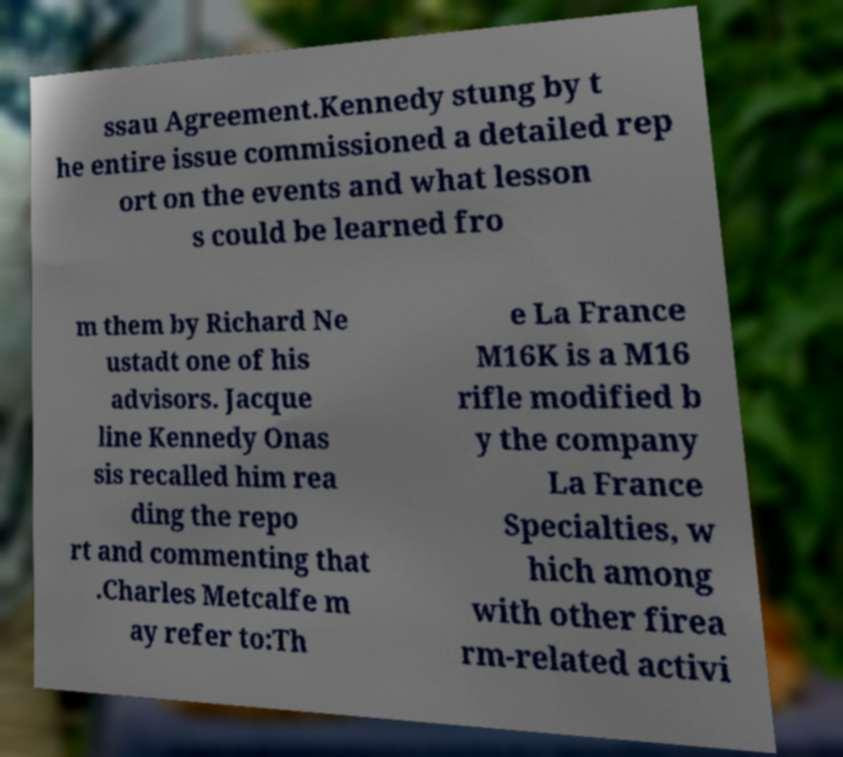Can you read and provide the text displayed in the image?This photo seems to have some interesting text. Can you extract and type it out for me? ssau Agreement.Kennedy stung by t he entire issue commissioned a detailed rep ort on the events and what lesson s could be learned fro m them by Richard Ne ustadt one of his advisors. Jacque line Kennedy Onas sis recalled him rea ding the repo rt and commenting that .Charles Metcalfe m ay refer to:Th e La France M16K is a M16 rifle modified b y the company La France Specialties, w hich among with other firea rm-related activi 